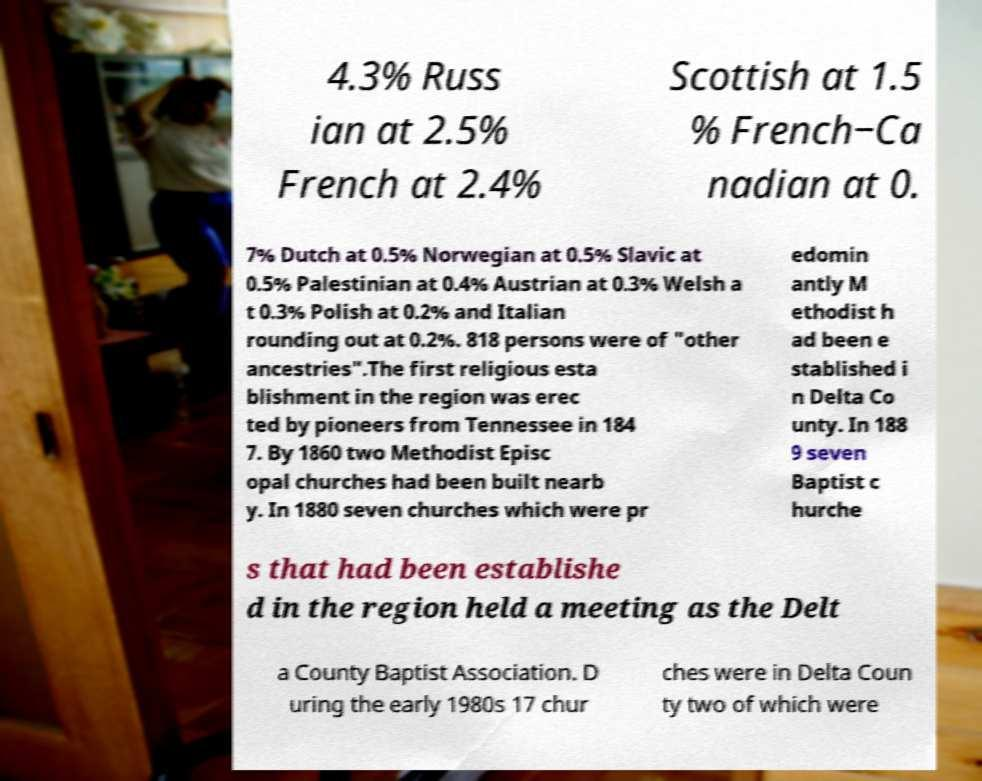Please identify and transcribe the text found in this image. 4.3% Russ ian at 2.5% French at 2.4% Scottish at 1.5 % French−Ca nadian at 0. 7% Dutch at 0.5% Norwegian at 0.5% Slavic at 0.5% Palestinian at 0.4% Austrian at 0.3% Welsh a t 0.3% Polish at 0.2% and Italian rounding out at 0.2%. 818 persons were of "other ancestries".The first religious esta blishment in the region was erec ted by pioneers from Tennessee in 184 7. By 1860 two Methodist Episc opal churches had been built nearb y. In 1880 seven churches which were pr edomin antly M ethodist h ad been e stablished i n Delta Co unty. In 188 9 seven Baptist c hurche s that had been establishe d in the region held a meeting as the Delt a County Baptist Association. D uring the early 1980s 17 chur ches were in Delta Coun ty two of which were 